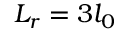<formula> <loc_0><loc_0><loc_500><loc_500>L _ { r } = 3 l _ { 0 }</formula> 